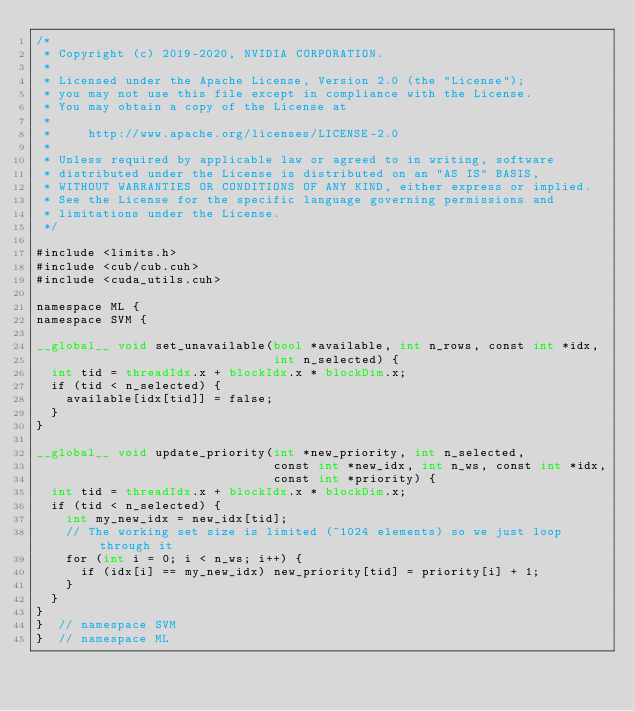<code> <loc_0><loc_0><loc_500><loc_500><_Cuda_>/*
 * Copyright (c) 2019-2020, NVIDIA CORPORATION.
 *
 * Licensed under the Apache License, Version 2.0 (the "License");
 * you may not use this file except in compliance with the License.
 * You may obtain a copy of the License at
 *
 *     http://www.apache.org/licenses/LICENSE-2.0
 *
 * Unless required by applicable law or agreed to in writing, software
 * distributed under the License is distributed on an "AS IS" BASIS,
 * WITHOUT WARRANTIES OR CONDITIONS OF ANY KIND, either express or implied.
 * See the License for the specific language governing permissions and
 * limitations under the License.
 */

#include <limits.h>
#include <cub/cub.cuh>
#include <cuda_utils.cuh>

namespace ML {
namespace SVM {

__global__ void set_unavailable(bool *available, int n_rows, const int *idx,
                                int n_selected) {
  int tid = threadIdx.x + blockIdx.x * blockDim.x;
  if (tid < n_selected) {
    available[idx[tid]] = false;
  }
}

__global__ void update_priority(int *new_priority, int n_selected,
                                const int *new_idx, int n_ws, const int *idx,
                                const int *priority) {
  int tid = threadIdx.x + blockIdx.x * blockDim.x;
  if (tid < n_selected) {
    int my_new_idx = new_idx[tid];
    // The working set size is limited (~1024 elements) so we just loop through it
    for (int i = 0; i < n_ws; i++) {
      if (idx[i] == my_new_idx) new_priority[tid] = priority[i] + 1;
    }
  }
}
}  // namespace SVM
}  // namespace ML
</code> 